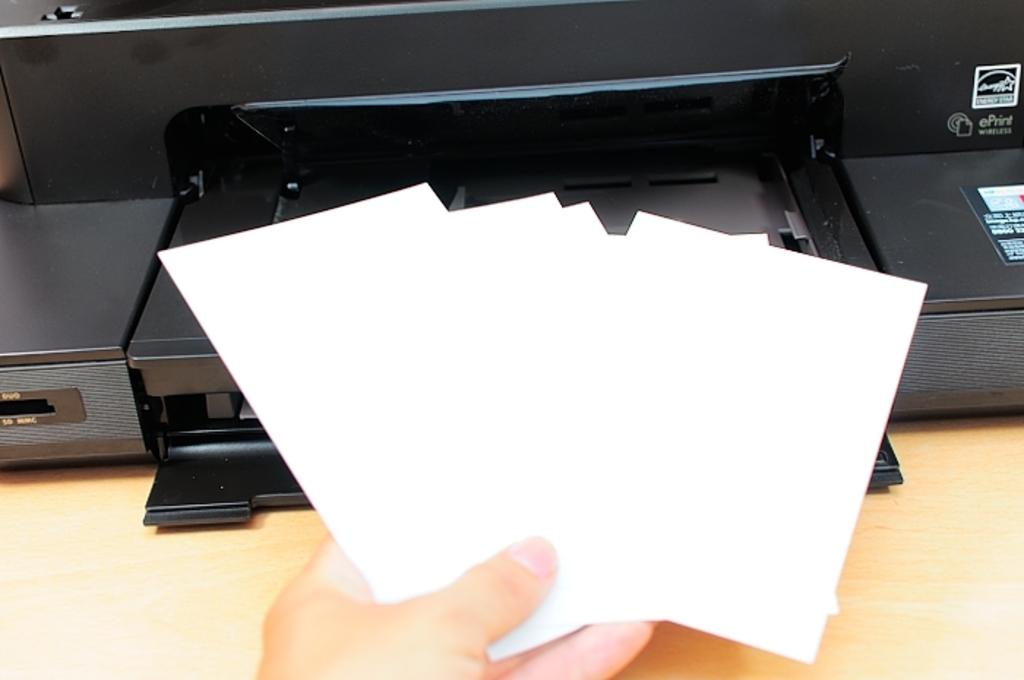What is the person's hand holding in the image? The person's hand is holding cards in the image. Can you describe anything in the background of the image? There is an object in the background that resembles a printer. What type of neck accessory is the writer wearing in the image? A: There is no writer or neck accessory present in the image; it only shows a person's hand holding cards and an object resembling a printer in the background. 